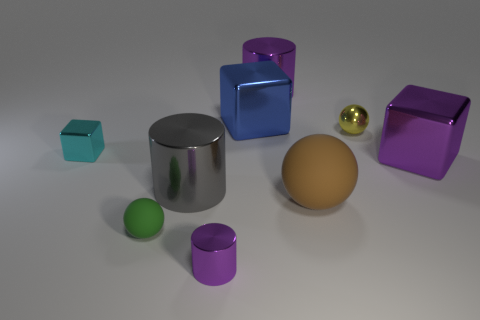There is a brown object that is made of the same material as the green object; what is its shape? The brown object, sharing the same smooth and reflective surface characteristics as the green object, is shaped like a sphere, showing a consistent curve in all directions. 